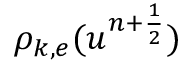Convert formula to latex. <formula><loc_0><loc_0><loc_500><loc_500>\rho _ { k , e } ( u ^ { n + \frac { 1 } { 2 } } )</formula> 